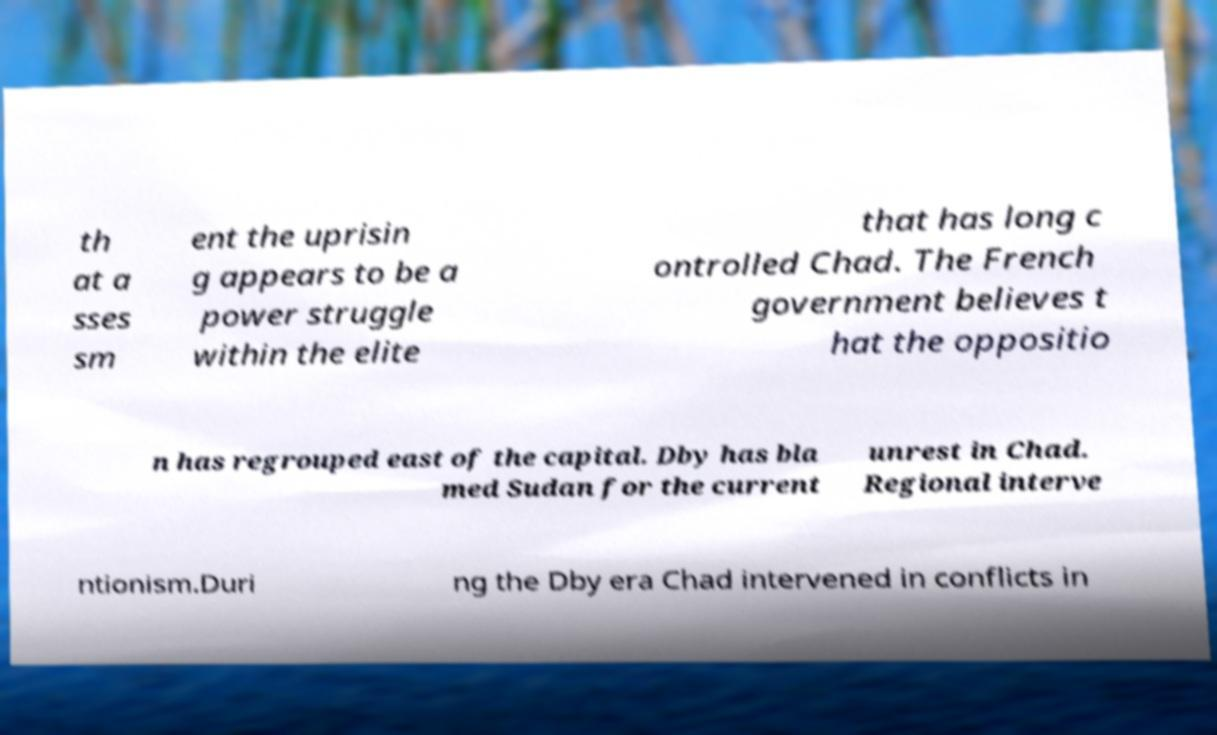Can you read and provide the text displayed in the image?This photo seems to have some interesting text. Can you extract and type it out for me? th at a sses sm ent the uprisin g appears to be a power struggle within the elite that has long c ontrolled Chad. The French government believes t hat the oppositio n has regrouped east of the capital. Dby has bla med Sudan for the current unrest in Chad. Regional interve ntionism.Duri ng the Dby era Chad intervened in conflicts in 